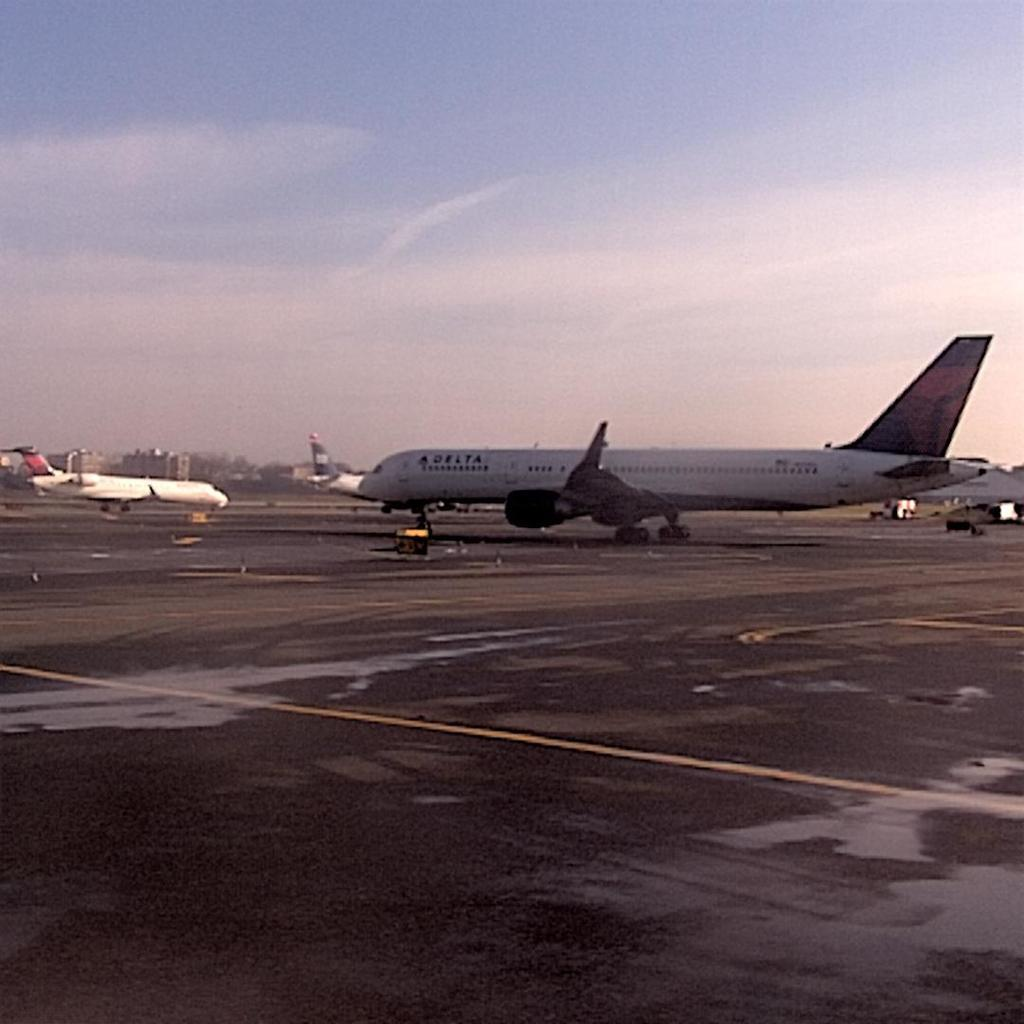What can be seen on the runway in the image? There are airplanes on the runway in the image. What else is visible in the background of the image? There are buildings visible behind the airplanes. What part of the natural environment is visible in the image? The sky is visible in the image. How many cents are visible on the sofa in the image? There is no sofa or cents present in the image. Can you describe the person sitting on the sofa in the image? There is no person or sofa present in the image. 